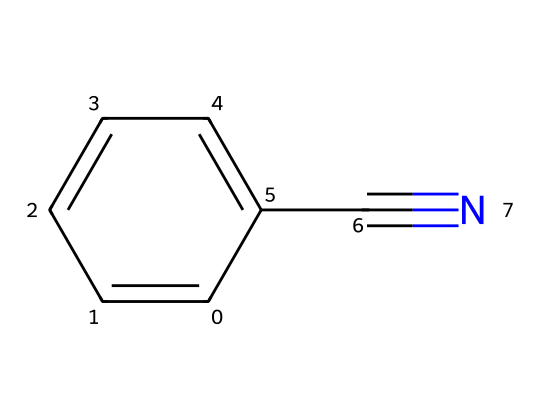What is the molecular formula of benzonitrile? The molecular formula can be determined by counting the number of carbon, hydrogen, and nitrogen atoms in the SMILES representation. There are 7 carbon atoms (c1ccccc1), 5 hydrogen atoms (the arrangement suggests 5 attached to the benzene ring), and 1 nitrogen atom (C#N indicates a nitrile group). This gives a total of C7H5N.
Answer: C7H5N How many rings are in the structure of benzonitrile? The structure contains a single benzene ring as indicated by the 'c' characters in the SMILES, which denotes aromatic carbon atoms. Hence, there is one cyclic structure present in benzonitrile.
Answer: 1 What type of functional group is present in benzonitrile? The presence of the -C≡N indicates that this compound contains a nitrile functional group, which is characteristic of compounds containing a carbon triple-bonded to a nitrogen.
Answer: nitrile Is benzonitrile polar or nonpolar? The presence of the electronegative nitrogen in the nitrile group (C#N) influences the polarity of the molecule, but the overall structure containing a large aromatic ring tends to make the molecule nonpolar. Thus, benzonitrile is generally considered to be nonpolar.
Answer: nonpolar What is the number of hydrogen atoms in benzonitrile? By analyzing the molecular formula derived from the SMILES notation, which is C7H5N, we can see there are 5 hydrogen atoms attached to the structure, specifically the benzene component, which has 5 hydrogen atoms after considering the nitrile's carbon atom.
Answer: 5 Why is benzonitrile used in some inks? Benzonitrile's aromatic structure makes it an effective solvent and produces stable colors, which are desirable qualities in ink formulations, particularly for financial documents that require durability and clarity.
Answer: stability 